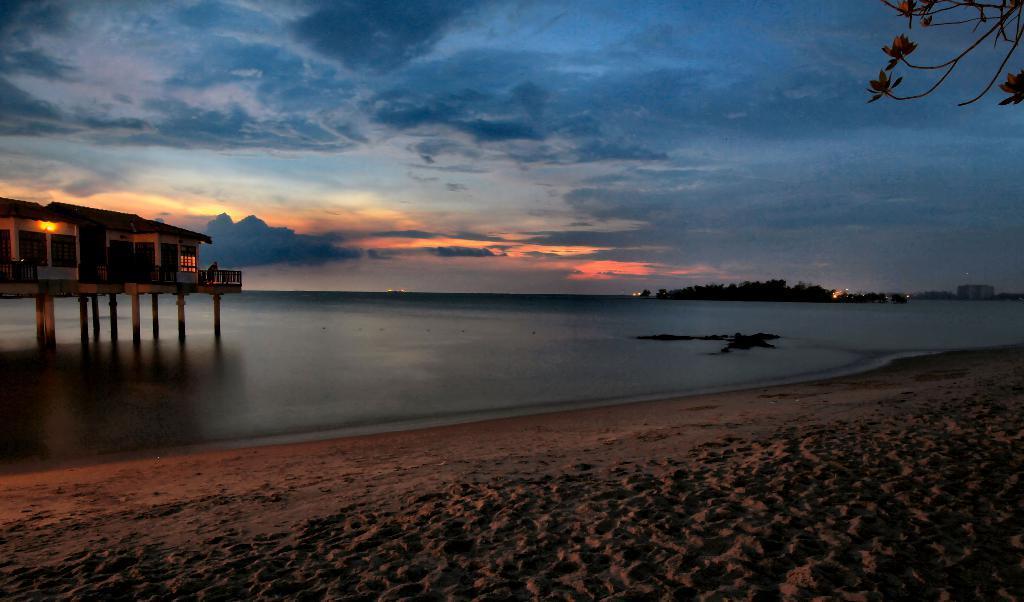Can you describe this image briefly? In this image there is a river, above the river there is a building. In the background there are trees, buildings and the sky. 